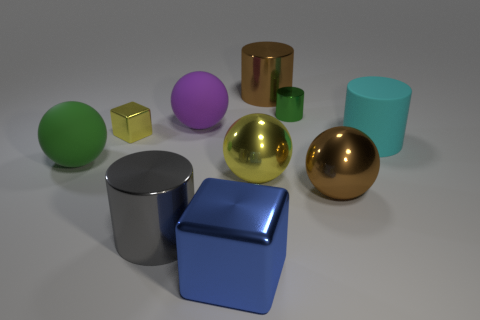Subtract all blue balls. Subtract all brown blocks. How many balls are left? 4 Subtract all spheres. How many objects are left? 6 Add 5 red matte objects. How many red matte objects exist? 5 Subtract 0 red blocks. How many objects are left? 10 Subtract all big purple blocks. Subtract all big green rubber objects. How many objects are left? 9 Add 4 green things. How many green things are left? 6 